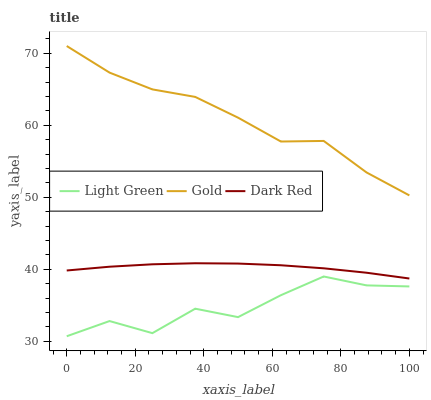Does Light Green have the minimum area under the curve?
Answer yes or no. Yes. Does Gold have the maximum area under the curve?
Answer yes or no. Yes. Does Gold have the minimum area under the curve?
Answer yes or no. No. Does Light Green have the maximum area under the curve?
Answer yes or no. No. Is Dark Red the smoothest?
Answer yes or no. Yes. Is Light Green the roughest?
Answer yes or no. Yes. Is Gold the smoothest?
Answer yes or no. No. Is Gold the roughest?
Answer yes or no. No. Does Light Green have the lowest value?
Answer yes or no. Yes. Does Gold have the lowest value?
Answer yes or no. No. Does Gold have the highest value?
Answer yes or no. Yes. Does Light Green have the highest value?
Answer yes or no. No. Is Light Green less than Dark Red?
Answer yes or no. Yes. Is Dark Red greater than Light Green?
Answer yes or no. Yes. Does Light Green intersect Dark Red?
Answer yes or no. No. 